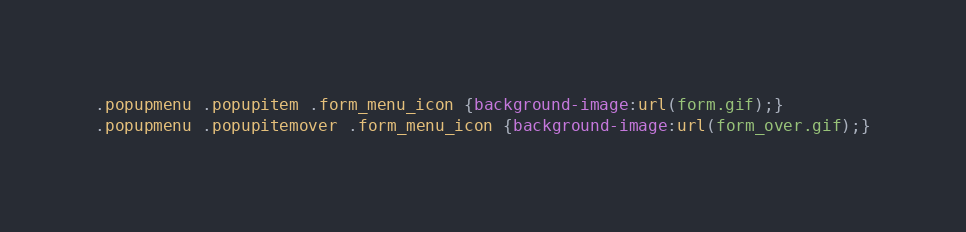Convert code to text. <code><loc_0><loc_0><loc_500><loc_500><_CSS_>.popupmenu .popupitem .form_menu_icon {background-image:url(form.gif);}
.popupmenu .popupitemover .form_menu_icon {background-image:url(form_over.gif);}

</code> 